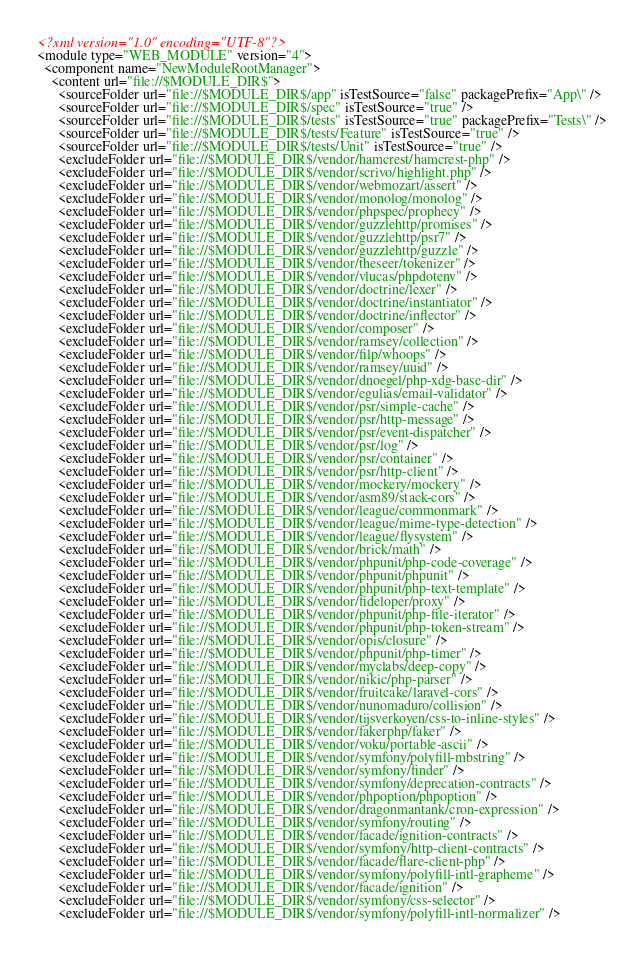Convert code to text. <code><loc_0><loc_0><loc_500><loc_500><_XML_><?xml version="1.0" encoding="UTF-8"?>
<module type="WEB_MODULE" version="4">
  <component name="NewModuleRootManager">
    <content url="file://$MODULE_DIR$">
      <sourceFolder url="file://$MODULE_DIR$/app" isTestSource="false" packagePrefix="App\" />
      <sourceFolder url="file://$MODULE_DIR$/spec" isTestSource="true" />
      <sourceFolder url="file://$MODULE_DIR$/tests" isTestSource="true" packagePrefix="Tests\" />
      <sourceFolder url="file://$MODULE_DIR$/tests/Feature" isTestSource="true" />
      <sourceFolder url="file://$MODULE_DIR$/tests/Unit" isTestSource="true" />
      <excludeFolder url="file://$MODULE_DIR$/vendor/hamcrest/hamcrest-php" />
      <excludeFolder url="file://$MODULE_DIR$/vendor/scrivo/highlight.php" />
      <excludeFolder url="file://$MODULE_DIR$/vendor/webmozart/assert" />
      <excludeFolder url="file://$MODULE_DIR$/vendor/monolog/monolog" />
      <excludeFolder url="file://$MODULE_DIR$/vendor/phpspec/prophecy" />
      <excludeFolder url="file://$MODULE_DIR$/vendor/guzzlehttp/promises" />
      <excludeFolder url="file://$MODULE_DIR$/vendor/guzzlehttp/psr7" />
      <excludeFolder url="file://$MODULE_DIR$/vendor/guzzlehttp/guzzle" />
      <excludeFolder url="file://$MODULE_DIR$/vendor/theseer/tokenizer" />
      <excludeFolder url="file://$MODULE_DIR$/vendor/vlucas/phpdotenv" />
      <excludeFolder url="file://$MODULE_DIR$/vendor/doctrine/lexer" />
      <excludeFolder url="file://$MODULE_DIR$/vendor/doctrine/instantiator" />
      <excludeFolder url="file://$MODULE_DIR$/vendor/doctrine/inflector" />
      <excludeFolder url="file://$MODULE_DIR$/vendor/composer" />
      <excludeFolder url="file://$MODULE_DIR$/vendor/ramsey/collection" />
      <excludeFolder url="file://$MODULE_DIR$/vendor/filp/whoops" />
      <excludeFolder url="file://$MODULE_DIR$/vendor/ramsey/uuid" />
      <excludeFolder url="file://$MODULE_DIR$/vendor/dnoegel/php-xdg-base-dir" />
      <excludeFolder url="file://$MODULE_DIR$/vendor/egulias/email-validator" />
      <excludeFolder url="file://$MODULE_DIR$/vendor/psr/simple-cache" />
      <excludeFolder url="file://$MODULE_DIR$/vendor/psr/http-message" />
      <excludeFolder url="file://$MODULE_DIR$/vendor/psr/event-dispatcher" />
      <excludeFolder url="file://$MODULE_DIR$/vendor/psr/log" />
      <excludeFolder url="file://$MODULE_DIR$/vendor/psr/container" />
      <excludeFolder url="file://$MODULE_DIR$/vendor/psr/http-client" />
      <excludeFolder url="file://$MODULE_DIR$/vendor/mockery/mockery" />
      <excludeFolder url="file://$MODULE_DIR$/vendor/asm89/stack-cors" />
      <excludeFolder url="file://$MODULE_DIR$/vendor/league/commonmark" />
      <excludeFolder url="file://$MODULE_DIR$/vendor/league/mime-type-detection" />
      <excludeFolder url="file://$MODULE_DIR$/vendor/league/flysystem" />
      <excludeFolder url="file://$MODULE_DIR$/vendor/brick/math" />
      <excludeFolder url="file://$MODULE_DIR$/vendor/phpunit/php-code-coverage" />
      <excludeFolder url="file://$MODULE_DIR$/vendor/phpunit/phpunit" />
      <excludeFolder url="file://$MODULE_DIR$/vendor/phpunit/php-text-template" />
      <excludeFolder url="file://$MODULE_DIR$/vendor/fideloper/proxy" />
      <excludeFolder url="file://$MODULE_DIR$/vendor/phpunit/php-file-iterator" />
      <excludeFolder url="file://$MODULE_DIR$/vendor/phpunit/php-token-stream" />
      <excludeFolder url="file://$MODULE_DIR$/vendor/opis/closure" />
      <excludeFolder url="file://$MODULE_DIR$/vendor/phpunit/php-timer" />
      <excludeFolder url="file://$MODULE_DIR$/vendor/myclabs/deep-copy" />
      <excludeFolder url="file://$MODULE_DIR$/vendor/nikic/php-parser" />
      <excludeFolder url="file://$MODULE_DIR$/vendor/fruitcake/laravel-cors" />
      <excludeFolder url="file://$MODULE_DIR$/vendor/nunomaduro/collision" />
      <excludeFolder url="file://$MODULE_DIR$/vendor/tijsverkoyen/css-to-inline-styles" />
      <excludeFolder url="file://$MODULE_DIR$/vendor/fakerphp/faker" />
      <excludeFolder url="file://$MODULE_DIR$/vendor/voku/portable-ascii" />
      <excludeFolder url="file://$MODULE_DIR$/vendor/symfony/polyfill-mbstring" />
      <excludeFolder url="file://$MODULE_DIR$/vendor/symfony/finder" />
      <excludeFolder url="file://$MODULE_DIR$/vendor/symfony/deprecation-contracts" />
      <excludeFolder url="file://$MODULE_DIR$/vendor/phpoption/phpoption" />
      <excludeFolder url="file://$MODULE_DIR$/vendor/dragonmantank/cron-expression" />
      <excludeFolder url="file://$MODULE_DIR$/vendor/symfony/routing" />
      <excludeFolder url="file://$MODULE_DIR$/vendor/facade/ignition-contracts" />
      <excludeFolder url="file://$MODULE_DIR$/vendor/symfony/http-client-contracts" />
      <excludeFolder url="file://$MODULE_DIR$/vendor/facade/flare-client-php" />
      <excludeFolder url="file://$MODULE_DIR$/vendor/symfony/polyfill-intl-grapheme" />
      <excludeFolder url="file://$MODULE_DIR$/vendor/facade/ignition" />
      <excludeFolder url="file://$MODULE_DIR$/vendor/symfony/css-selector" />
      <excludeFolder url="file://$MODULE_DIR$/vendor/symfony/polyfill-intl-normalizer" /></code> 